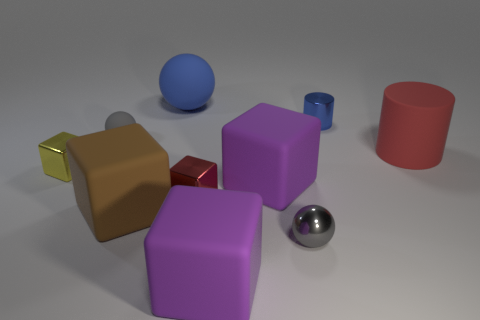Subtract all shiny balls. How many balls are left? 2 Subtract all red cubes. How many gray balls are left? 2 Subtract all purple cubes. How many cubes are left? 3 Subtract all red balls. Subtract all brown cylinders. How many balls are left? 3 Subtract 0 red spheres. How many objects are left? 10 Subtract all balls. How many objects are left? 7 Subtract all blue rubber objects. Subtract all yellow metal cubes. How many objects are left? 8 Add 3 tiny blue objects. How many tiny blue objects are left? 4 Add 4 large cyan shiny balls. How many large cyan shiny balls exist? 4 